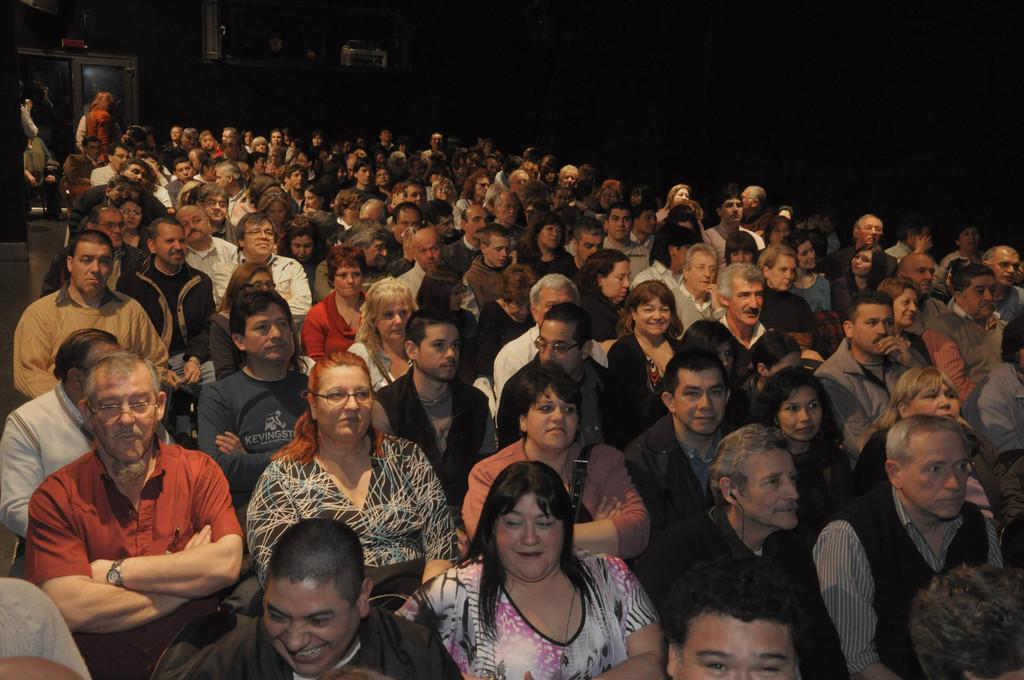Please provide a concise description of this image. Many people are seated. Few people are standing at the back. There is a door at the back and the background is blurred. 